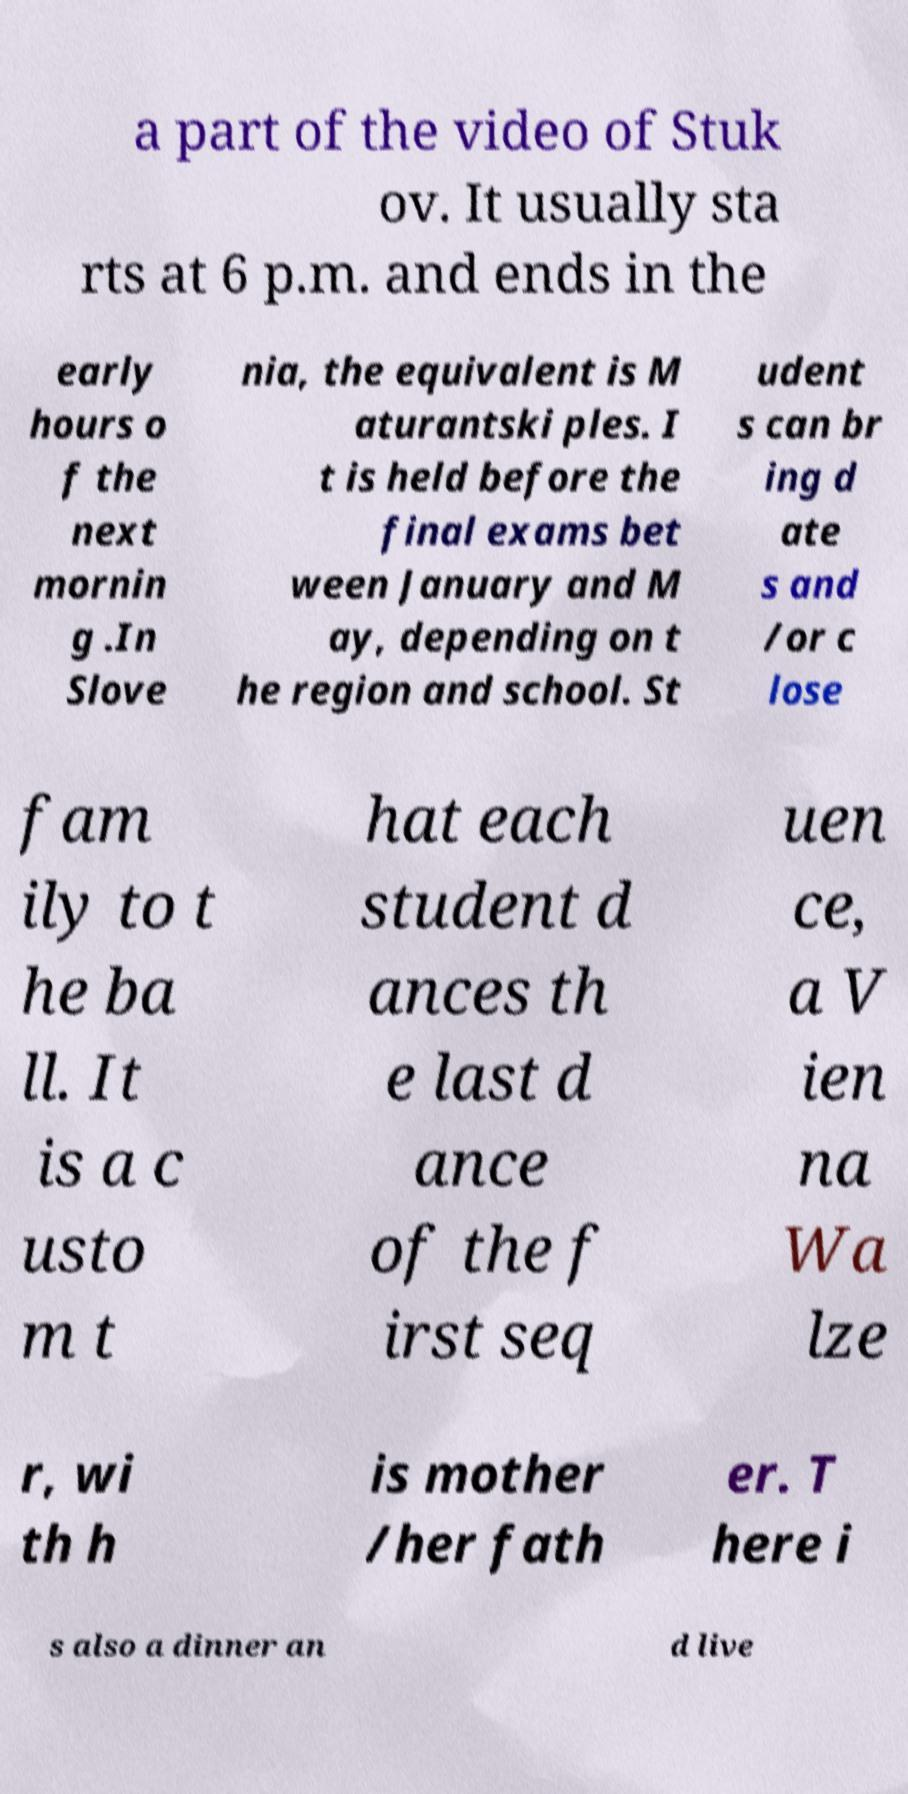Please read and relay the text visible in this image. What does it say? a part of the video of Stuk ov. It usually sta rts at 6 p.m. and ends in the early hours o f the next mornin g .In Slove nia, the equivalent is M aturantski ples. I t is held before the final exams bet ween January and M ay, depending on t he region and school. St udent s can br ing d ate s and /or c lose fam ily to t he ba ll. It is a c usto m t hat each student d ances th e last d ance of the f irst seq uen ce, a V ien na Wa lze r, wi th h is mother /her fath er. T here i s also a dinner an d live 